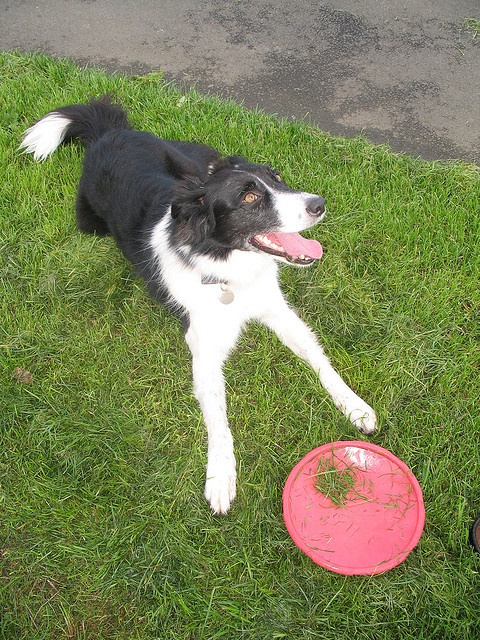Describe the objects in this image and their specific colors. I can see dog in gray, white, black, and darkgray tones and frisbee in gray, lightpink, salmon, and olive tones in this image. 